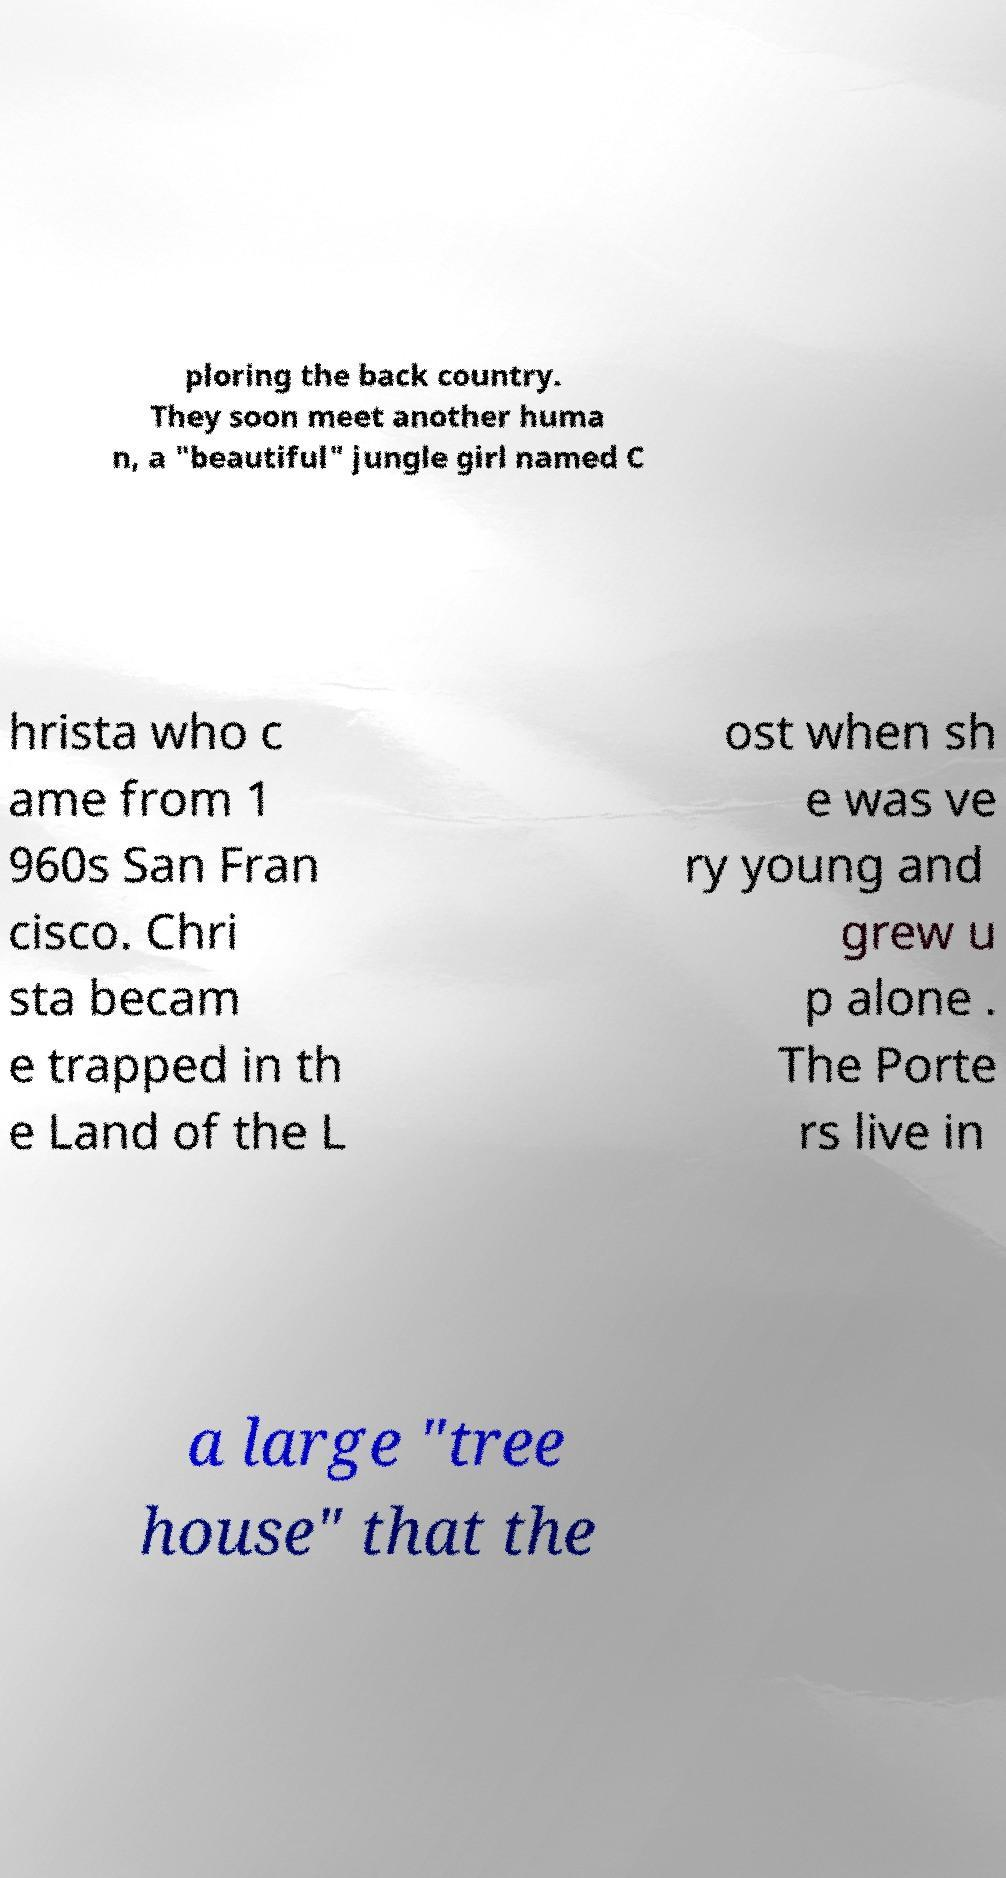I need the written content from this picture converted into text. Can you do that? ploring the back country. They soon meet another huma n, a "beautiful" jungle girl named C hrista who c ame from 1 960s San Fran cisco. Chri sta becam e trapped in th e Land of the L ost when sh e was ve ry young and grew u p alone . The Porte rs live in a large "tree house" that the 